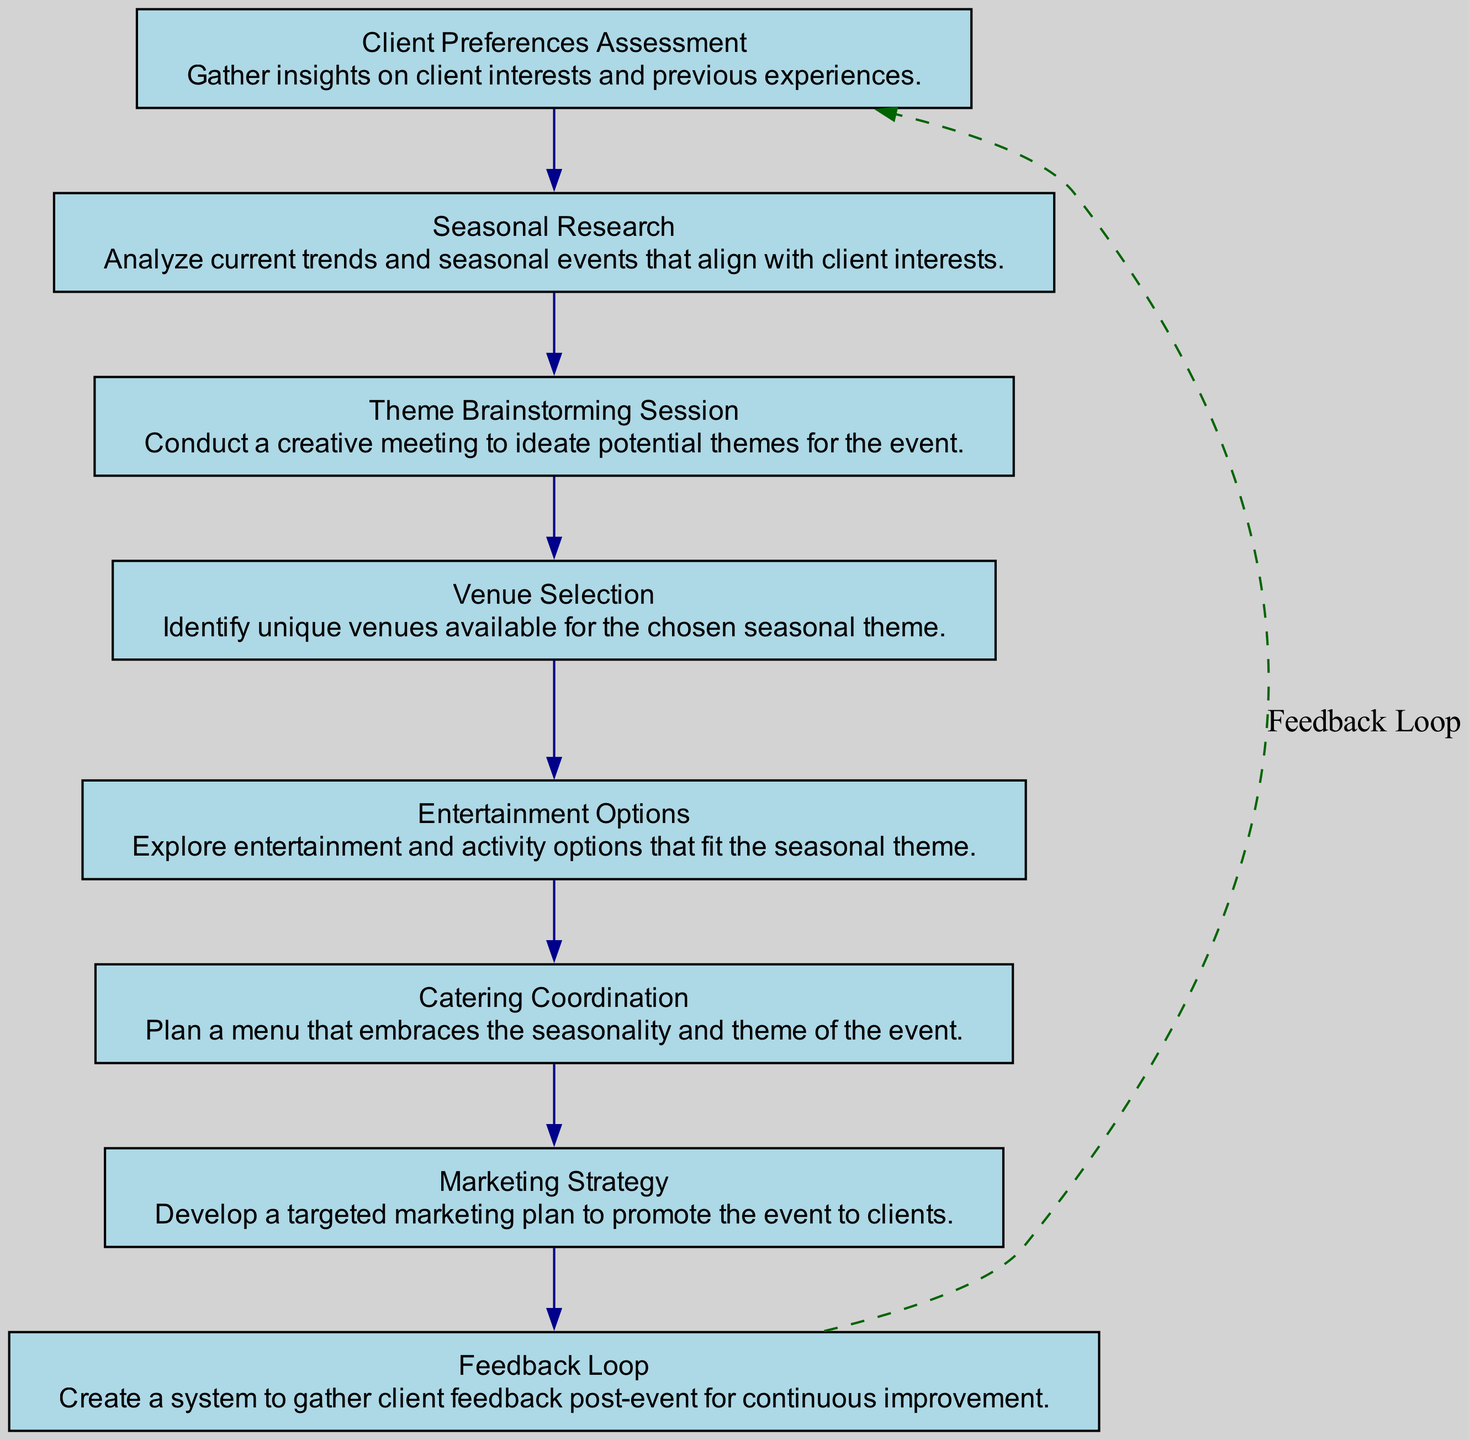What is the final step in the flow chart? The last step in the flow chart is "Feedback Loop," which is indicated as the process that occurs after all prior elements.
Answer: Feedback Loop How many total nodes are in the diagram? The diagram contains eight distinct elements or nodes that represent the processes involved in seasonal theme ideation.
Answer: Eight Which step follows "Seasonal Research"? The step that immediately follows "Seasonal Research" is "Theme Brainstorming Session," which is connected directly by an edge.
Answer: Theme Brainstorming Session What is the primary purpose of the "Catering Coordination"? The purpose of "Catering Coordination" is to plan a menu, as described in its node text, that aligns with the seasonal theme being employed for the event.
Answer: Plan a menu Which aspect connects "Feedback Loop" back to the first step? The "Feedback Loop" is designed with a dashed line, indicating its role in reconnecting to the "Client Preferences Assessment" step after the event for ongoing improvements.
Answer: Dashed line What is the common theme in the first two steps of the flowchart? The common theme in the first two steps, "Client Preferences Assessment" and "Seasonal Research," is gathering information to inform future decisions about the event's theme.
Answer: Information gathering What type of venues is identified in the "Venue Selection" step? The "Venue Selection" step emphasizes identifying unique venues that align with the chosen seasonal theme, making it clear that the selection is thematic.
Answer: Unique venues Which two steps are related directly by a single edge? The steps "Theme Brainstorming Session" and "Venue Selection" are directly linked by a single edge, showing a sequential relationship in the ideation process.
Answer: Theme Brainstorming Session and Venue Selection 